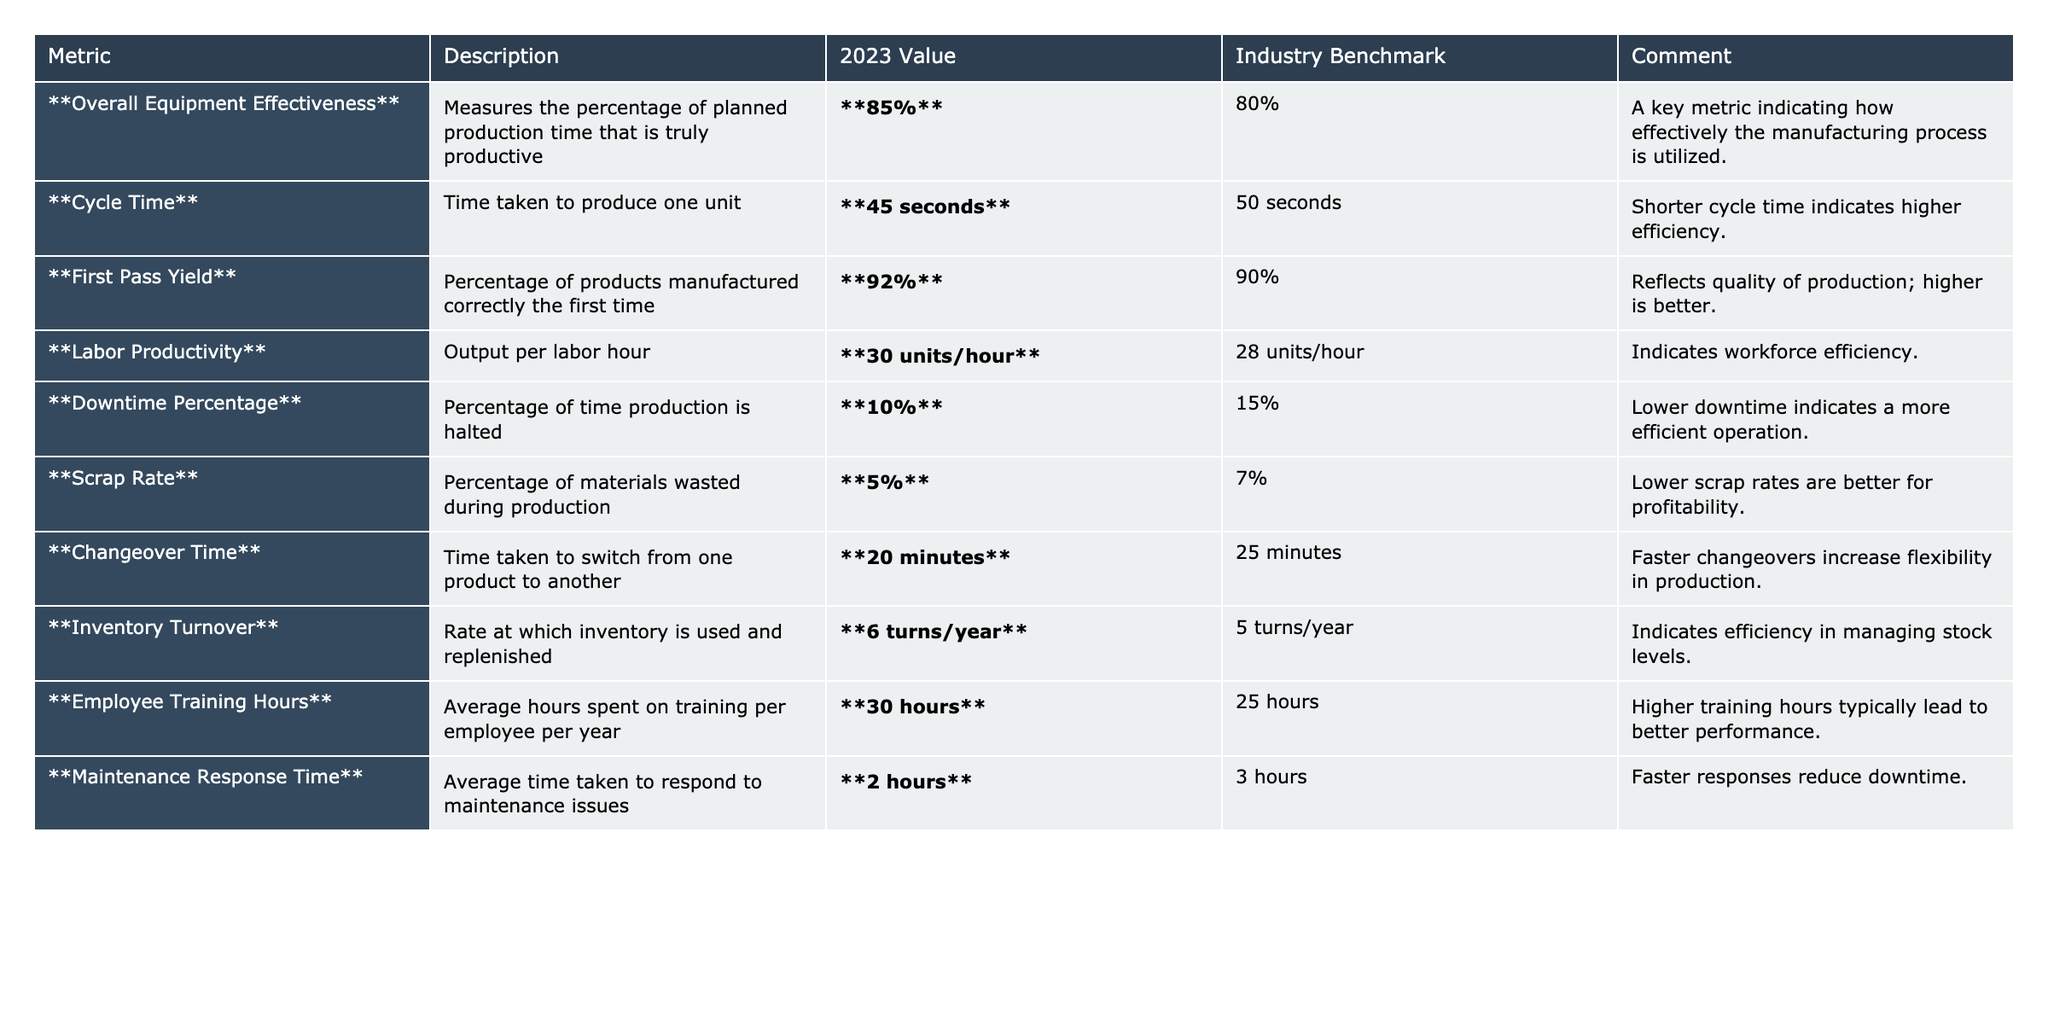What is the Overall Equipment Effectiveness for 2023? The Overall Equipment Effectiveness value for 2023 is directly stated in the table as 85%.
Answer: 85% What is the Industry Benchmark for Scrap Rate? The Industry Benchmark for Scrap Rate is listed in the table as 7%.
Answer: 7% Which metric has the lowest value for 2023? By comparing all the values in the '2023 Value' column, the lowest value is for the Scrap Rate, which is 5%.
Answer: 5% Is the Labor Productivity for 2023 above or below the Industry Benchmark? The Labor Productivity for 2023 is 30 units/hour, and the Industry Benchmark is 28 units/hour, which means it is above the benchmark.
Answer: Above What is the difference in Maintenance Response Time between 2023 and the Industry Benchmark? The Maintenance Response Time for 2023 is 2 hours and the Industry Benchmark is 3 hours. The difference is 3 - 2 = 1 hour.
Answer: 1 hour What percentage improvement in Changeover Time does the 2023 value represent against the Industry Benchmark? The Changeover Time for 2023 is 20 minutes, while the Industry Benchmark is 25 minutes. The improvement is (25 - 20) / 25 * 100% = 20%.
Answer: 20% How does the First Pass Yield compare to the Industry Benchmark? The First Pass Yield for 2023 is 92%, which is higher than the Industry Benchmark of 90%.
Answer: Higher What is the ratio of Inventory Turnover to Downtime Percentage for 2023? The Inventory Turnover is 6 turns/year and the Downtime Percentage is 10%. The ratio is 6 / 10 = 0.6.
Answer: 0.6 How many more Employee Training Hours does the 2023 value have compared to the Industry Benchmark? The 2023 value for Employee Training Hours is 30 hours, which is more than the Industry Benchmark of 25 hours. The difference is 30 - 25 = 5 hours.
Answer: 5 hours Considering both Labor Productivity and Overall Equipment Effectiveness, which metric shows a better performance compared to its Industry Benchmark? Labor Productivity is 30 units/hour (above 28 units/hour benchmark) and Overall Equipment Effectiveness is 85% (above 80% benchmark). Both show better performance compared to their benchmarks.
Answer: Both metrics show better performance 